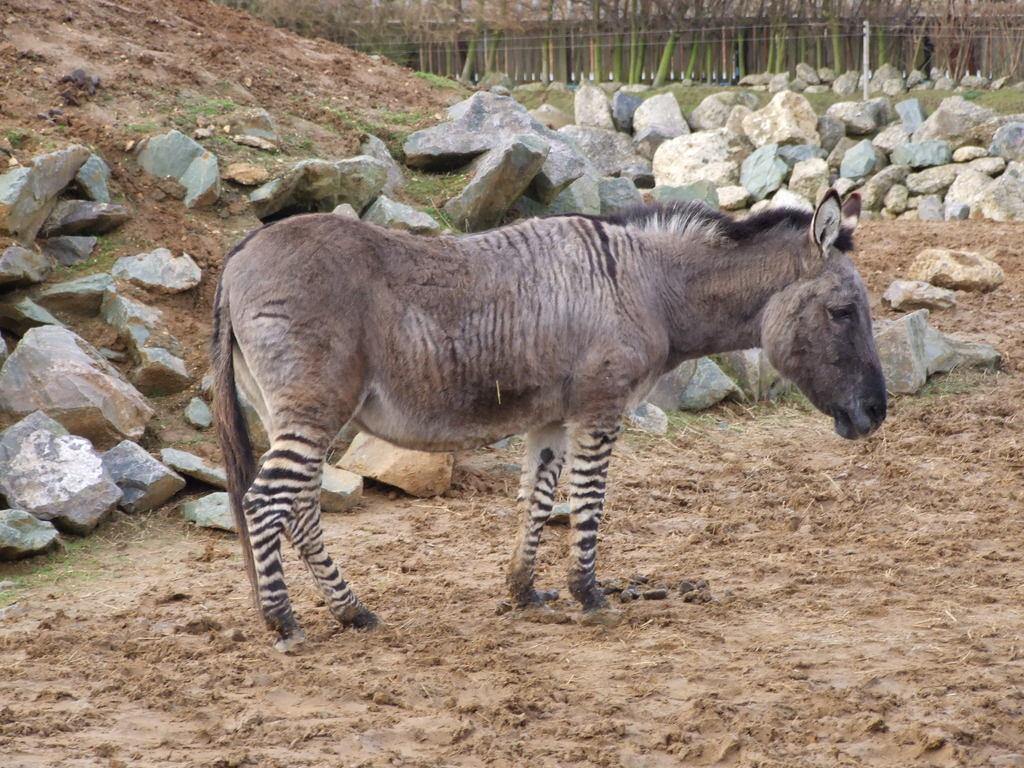Where was the picture taken? The picture was clicked outside. What is the main subject of the image? There is an animal standing in the center of the image. What is the animal standing on? The animal is standing on the ground. What can be seen in the background of the image? There are rocks, other objects, and grass visible in the background of the image. What type of quiet prison can be seen in the background of the image? There is no prison present in the image; it features an animal standing on the ground with rocks, other objects, and grass visible in the background. 